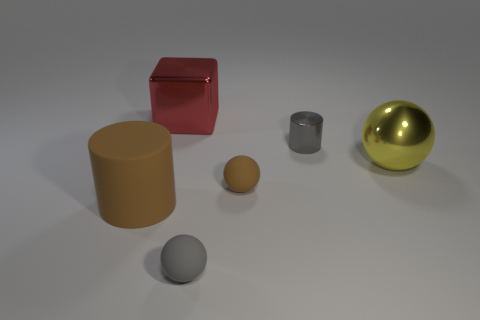What shape is the shiny thing that is behind the metal ball and on the right side of the red metal cube?
Your answer should be compact. Cylinder. Is there another gray cylinder of the same size as the gray cylinder?
Offer a terse response. No. What number of objects are either gray things that are in front of the tiny metal object or yellow metal balls?
Make the answer very short. 2. Does the large brown cylinder have the same material as the small gray thing behind the big brown matte thing?
Ensure brevity in your answer.  No. How many other objects are there of the same shape as the small shiny object?
Make the answer very short. 1. What number of objects are either big shiny objects to the right of the large red metal block or tiny matte spheres that are in front of the big brown rubber cylinder?
Keep it short and to the point. 2. How many other objects are there of the same color as the metallic cylinder?
Offer a very short reply. 1. Are there fewer large brown matte things that are behind the tiny gray metal thing than balls that are in front of the tiny gray rubber thing?
Give a very brief answer. No. What number of yellow balls are there?
Make the answer very short. 1. Is there any other thing that is the same material as the tiny brown object?
Provide a succinct answer. Yes. 